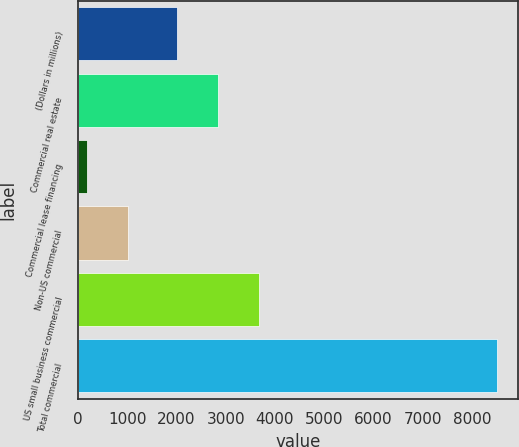Convert chart. <chart><loc_0><loc_0><loc_500><loc_500><bar_chart><fcel>(Dollars in millions)<fcel>Commercial real estate<fcel>Commercial lease financing<fcel>Non-US commercial<fcel>US small business commercial<fcel>Total commercial<nl><fcel>2009<fcel>2840.5<fcel>195<fcel>1026.5<fcel>3672<fcel>8510<nl></chart> 